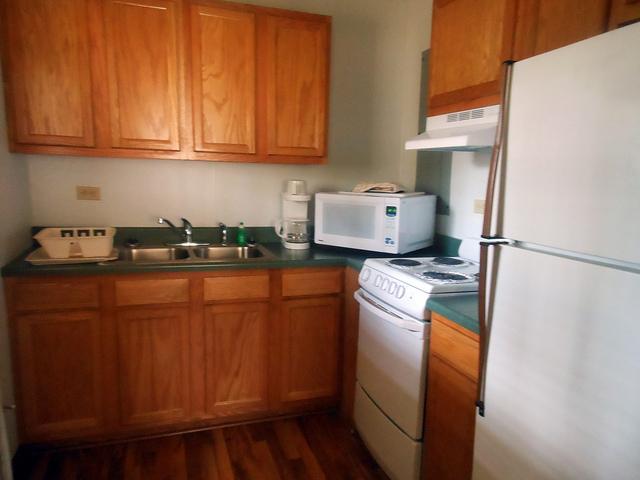How many microwaves are there?
Be succinct. 1. What color is the dish soap?
Be succinct. Green. Has this kitchen been updated?
Give a very brief answer. No. 